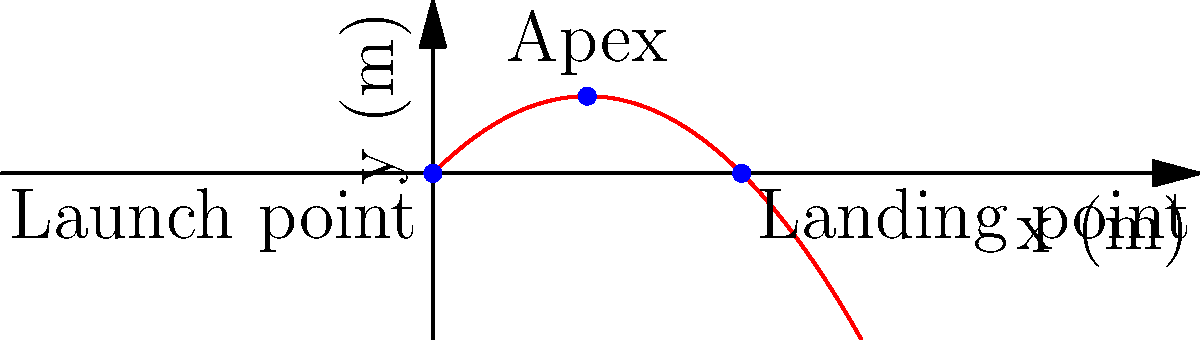In a softball game, you're helping your friend optimize their throw. Assuming the softball is thrown with an initial velocity of 20 m/s at a 45-degree angle, and neglecting air resistance, calculate:
a) The maximum height reached by the softball
b) The total horizontal distance traveled
c) The time taken for the softball to reach its maximum height

Use g = 9.8 m/s² for the acceleration due to gravity. Round your answers to two decimal places. Let's approach this step-by-step using the equations of projectile motion:

1) Initial velocity components:
   $v_{0x} = v_0 \cos \theta = 20 \cos 45° = 20 \cdot \frac{\sqrt{2}}{2} = 10\sqrt{2}$ m/s
   $v_{0y} = v_0 \sin \theta = 20 \sin 45° = 20 \cdot \frac{\sqrt{2}}{2} = 10\sqrt{2}$ m/s

2) Time to reach maximum height:
   At the highest point, $v_y = 0$
   $v_y = v_{0y} - gt$
   $0 = 10\sqrt{2} - 9.8t$
   $t = \frac{10\sqrt{2}}{9.8} = 1.44$ s

3) Maximum height:
   $y_{max} = v_{0y}t - \frac{1}{2}gt^2$
   $y_{max} = (10\sqrt{2})(1.44) - \frac{1}{2}(9.8)(1.44)^2$
   $y_{max} = 10.20$ m

4) Total time of flight:
   Total time is twice the time to reach maximum height
   $T = 2(1.44) = 2.88$ s

5) Horizontal distance:
   $x = v_{0x}T$
   $x = (10\sqrt{2})(2.88) = 40.81$ m

Therefore:
a) Maximum height = 10.20 m
b) Total horizontal distance = 40.81 m
c) Time to reach maximum height = 1.44 s
Answer: a) 10.20 m
b) 40.81 m
c) 1.44 s 